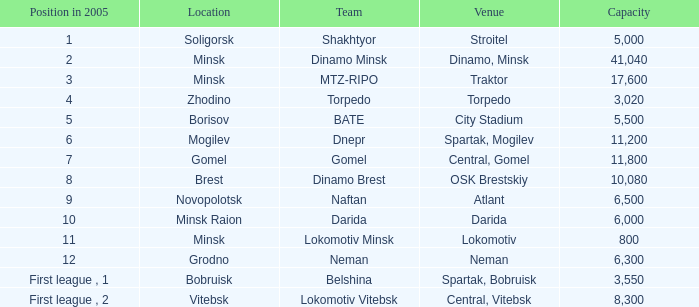Can you tell me the Capacity that has the Position in 2005 of 8? 10080.0. 